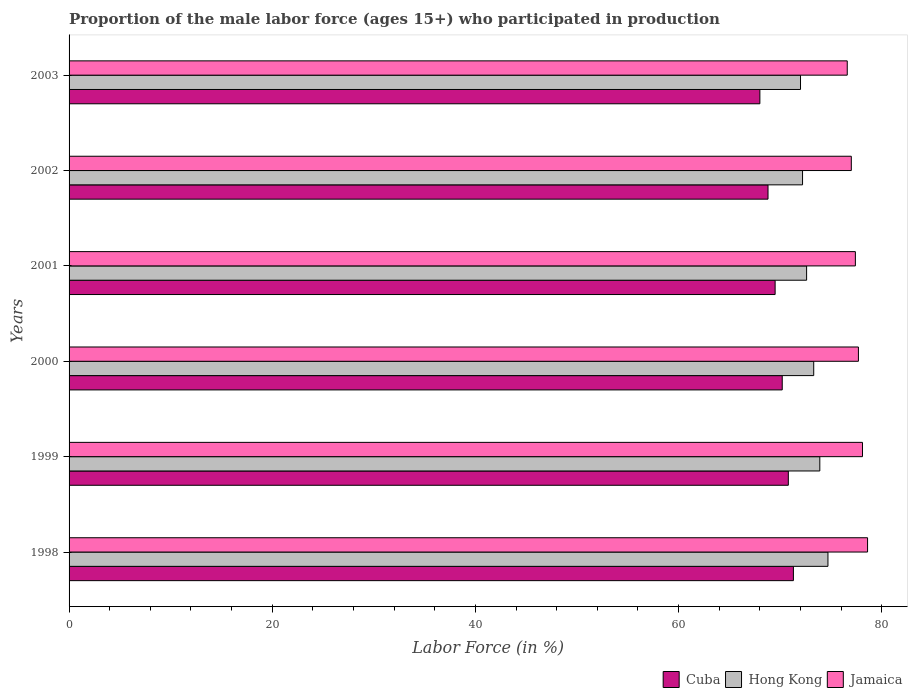How many different coloured bars are there?
Ensure brevity in your answer.  3. How many groups of bars are there?
Provide a succinct answer. 6. Are the number of bars on each tick of the Y-axis equal?
Make the answer very short. Yes. What is the label of the 2nd group of bars from the top?
Offer a terse response. 2002. In how many cases, is the number of bars for a given year not equal to the number of legend labels?
Offer a terse response. 0. What is the proportion of the male labor force who participated in production in Cuba in 2003?
Keep it short and to the point. 68. Across all years, what is the maximum proportion of the male labor force who participated in production in Cuba?
Give a very brief answer. 71.3. Across all years, what is the minimum proportion of the male labor force who participated in production in Jamaica?
Provide a short and direct response. 76.6. In which year was the proportion of the male labor force who participated in production in Cuba maximum?
Offer a very short reply. 1998. In which year was the proportion of the male labor force who participated in production in Cuba minimum?
Give a very brief answer. 2003. What is the total proportion of the male labor force who participated in production in Hong Kong in the graph?
Give a very brief answer. 438.7. What is the difference between the proportion of the male labor force who participated in production in Jamaica in 2000 and that in 2002?
Make the answer very short. 0.7. What is the difference between the proportion of the male labor force who participated in production in Hong Kong in 1999 and the proportion of the male labor force who participated in production in Cuba in 2003?
Your answer should be very brief. 5.9. What is the average proportion of the male labor force who participated in production in Hong Kong per year?
Keep it short and to the point. 73.12. In the year 2001, what is the difference between the proportion of the male labor force who participated in production in Hong Kong and proportion of the male labor force who participated in production in Cuba?
Your response must be concise. 3.1. In how many years, is the proportion of the male labor force who participated in production in Cuba greater than 4 %?
Give a very brief answer. 6. What is the ratio of the proportion of the male labor force who participated in production in Cuba in 2002 to that in 2003?
Your answer should be very brief. 1.01. Is the difference between the proportion of the male labor force who participated in production in Hong Kong in 2000 and 2002 greater than the difference between the proportion of the male labor force who participated in production in Cuba in 2000 and 2002?
Make the answer very short. No. Is the sum of the proportion of the male labor force who participated in production in Cuba in 1999 and 2000 greater than the maximum proportion of the male labor force who participated in production in Jamaica across all years?
Keep it short and to the point. Yes. What does the 2nd bar from the top in 2003 represents?
Ensure brevity in your answer.  Hong Kong. What does the 2nd bar from the bottom in 2000 represents?
Give a very brief answer. Hong Kong. Is it the case that in every year, the sum of the proportion of the male labor force who participated in production in Jamaica and proportion of the male labor force who participated in production in Cuba is greater than the proportion of the male labor force who participated in production in Hong Kong?
Your response must be concise. Yes. What is the difference between two consecutive major ticks on the X-axis?
Make the answer very short. 20. Are the values on the major ticks of X-axis written in scientific E-notation?
Your response must be concise. No. Where does the legend appear in the graph?
Keep it short and to the point. Bottom right. How are the legend labels stacked?
Provide a short and direct response. Horizontal. What is the title of the graph?
Make the answer very short. Proportion of the male labor force (ages 15+) who participated in production. What is the Labor Force (in %) of Cuba in 1998?
Ensure brevity in your answer.  71.3. What is the Labor Force (in %) in Hong Kong in 1998?
Give a very brief answer. 74.7. What is the Labor Force (in %) in Jamaica in 1998?
Your answer should be compact. 78.6. What is the Labor Force (in %) of Cuba in 1999?
Offer a terse response. 70.8. What is the Labor Force (in %) in Hong Kong in 1999?
Offer a terse response. 73.9. What is the Labor Force (in %) in Jamaica in 1999?
Your answer should be compact. 78.1. What is the Labor Force (in %) of Cuba in 2000?
Give a very brief answer. 70.2. What is the Labor Force (in %) in Hong Kong in 2000?
Your response must be concise. 73.3. What is the Labor Force (in %) in Jamaica in 2000?
Offer a very short reply. 77.7. What is the Labor Force (in %) of Cuba in 2001?
Your response must be concise. 69.5. What is the Labor Force (in %) in Hong Kong in 2001?
Offer a very short reply. 72.6. What is the Labor Force (in %) in Jamaica in 2001?
Ensure brevity in your answer.  77.4. What is the Labor Force (in %) in Cuba in 2002?
Give a very brief answer. 68.8. What is the Labor Force (in %) in Hong Kong in 2002?
Offer a terse response. 72.2. What is the Labor Force (in %) of Jamaica in 2002?
Your answer should be very brief. 77. What is the Labor Force (in %) of Jamaica in 2003?
Your answer should be compact. 76.6. Across all years, what is the maximum Labor Force (in %) in Cuba?
Provide a short and direct response. 71.3. Across all years, what is the maximum Labor Force (in %) of Hong Kong?
Your answer should be very brief. 74.7. Across all years, what is the maximum Labor Force (in %) in Jamaica?
Offer a very short reply. 78.6. Across all years, what is the minimum Labor Force (in %) of Hong Kong?
Your response must be concise. 72. Across all years, what is the minimum Labor Force (in %) of Jamaica?
Your answer should be very brief. 76.6. What is the total Labor Force (in %) of Cuba in the graph?
Offer a terse response. 418.6. What is the total Labor Force (in %) in Hong Kong in the graph?
Ensure brevity in your answer.  438.7. What is the total Labor Force (in %) of Jamaica in the graph?
Ensure brevity in your answer.  465.4. What is the difference between the Labor Force (in %) in Cuba in 1998 and that in 1999?
Offer a very short reply. 0.5. What is the difference between the Labor Force (in %) of Cuba in 1998 and that in 2000?
Provide a short and direct response. 1.1. What is the difference between the Labor Force (in %) in Hong Kong in 1998 and that in 2000?
Your answer should be very brief. 1.4. What is the difference between the Labor Force (in %) of Cuba in 1998 and that in 2001?
Your answer should be compact. 1.8. What is the difference between the Labor Force (in %) of Jamaica in 1998 and that in 2001?
Make the answer very short. 1.2. What is the difference between the Labor Force (in %) of Cuba in 1998 and that in 2002?
Your response must be concise. 2.5. What is the difference between the Labor Force (in %) in Hong Kong in 1998 and that in 2003?
Offer a very short reply. 2.7. What is the difference between the Labor Force (in %) in Jamaica in 1998 and that in 2003?
Offer a terse response. 2. What is the difference between the Labor Force (in %) in Cuba in 1999 and that in 2000?
Give a very brief answer. 0.6. What is the difference between the Labor Force (in %) in Hong Kong in 1999 and that in 2000?
Your answer should be compact. 0.6. What is the difference between the Labor Force (in %) of Jamaica in 1999 and that in 2000?
Give a very brief answer. 0.4. What is the difference between the Labor Force (in %) of Jamaica in 1999 and that in 2001?
Offer a very short reply. 0.7. What is the difference between the Labor Force (in %) in Jamaica in 1999 and that in 2002?
Make the answer very short. 1.1. What is the difference between the Labor Force (in %) of Cuba in 1999 and that in 2003?
Ensure brevity in your answer.  2.8. What is the difference between the Labor Force (in %) in Hong Kong in 1999 and that in 2003?
Ensure brevity in your answer.  1.9. What is the difference between the Labor Force (in %) in Cuba in 2000 and that in 2001?
Provide a succinct answer. 0.7. What is the difference between the Labor Force (in %) in Hong Kong in 2000 and that in 2001?
Offer a very short reply. 0.7. What is the difference between the Labor Force (in %) of Jamaica in 2000 and that in 2001?
Make the answer very short. 0.3. What is the difference between the Labor Force (in %) of Hong Kong in 2000 and that in 2002?
Give a very brief answer. 1.1. What is the difference between the Labor Force (in %) of Jamaica in 2000 and that in 2002?
Your response must be concise. 0.7. What is the difference between the Labor Force (in %) in Hong Kong in 2000 and that in 2003?
Give a very brief answer. 1.3. What is the difference between the Labor Force (in %) of Cuba in 2001 and that in 2002?
Ensure brevity in your answer.  0.7. What is the difference between the Labor Force (in %) of Cuba in 2001 and that in 2003?
Give a very brief answer. 1.5. What is the difference between the Labor Force (in %) in Jamaica in 2001 and that in 2003?
Provide a succinct answer. 0.8. What is the difference between the Labor Force (in %) of Hong Kong in 2002 and that in 2003?
Offer a terse response. 0.2. What is the difference between the Labor Force (in %) in Cuba in 1998 and the Labor Force (in %) in Jamaica in 2000?
Offer a terse response. -6.4. What is the difference between the Labor Force (in %) of Hong Kong in 1998 and the Labor Force (in %) of Jamaica in 2000?
Your answer should be compact. -3. What is the difference between the Labor Force (in %) in Cuba in 1998 and the Labor Force (in %) in Hong Kong in 2001?
Offer a terse response. -1.3. What is the difference between the Labor Force (in %) in Cuba in 1998 and the Labor Force (in %) in Jamaica in 2001?
Make the answer very short. -6.1. What is the difference between the Labor Force (in %) in Cuba in 1998 and the Labor Force (in %) in Hong Kong in 2002?
Your answer should be very brief. -0.9. What is the difference between the Labor Force (in %) in Hong Kong in 1998 and the Labor Force (in %) in Jamaica in 2002?
Offer a terse response. -2.3. What is the difference between the Labor Force (in %) of Cuba in 1998 and the Labor Force (in %) of Hong Kong in 2003?
Make the answer very short. -0.7. What is the difference between the Labor Force (in %) in Cuba in 1998 and the Labor Force (in %) in Jamaica in 2003?
Your response must be concise. -5.3. What is the difference between the Labor Force (in %) in Hong Kong in 1998 and the Labor Force (in %) in Jamaica in 2003?
Provide a succinct answer. -1.9. What is the difference between the Labor Force (in %) in Cuba in 1999 and the Labor Force (in %) in Hong Kong in 2000?
Ensure brevity in your answer.  -2.5. What is the difference between the Labor Force (in %) of Cuba in 1999 and the Labor Force (in %) of Jamaica in 2000?
Your response must be concise. -6.9. What is the difference between the Labor Force (in %) in Hong Kong in 1999 and the Labor Force (in %) in Jamaica in 2000?
Give a very brief answer. -3.8. What is the difference between the Labor Force (in %) of Cuba in 1999 and the Labor Force (in %) of Hong Kong in 2001?
Give a very brief answer. -1.8. What is the difference between the Labor Force (in %) in Cuba in 1999 and the Labor Force (in %) in Hong Kong in 2002?
Offer a terse response. -1.4. What is the difference between the Labor Force (in %) of Cuba in 1999 and the Labor Force (in %) of Jamaica in 2002?
Provide a short and direct response. -6.2. What is the difference between the Labor Force (in %) of Cuba in 1999 and the Labor Force (in %) of Hong Kong in 2003?
Your answer should be very brief. -1.2. What is the difference between the Labor Force (in %) of Cuba in 2000 and the Labor Force (in %) of Hong Kong in 2001?
Make the answer very short. -2.4. What is the difference between the Labor Force (in %) of Hong Kong in 2000 and the Labor Force (in %) of Jamaica in 2002?
Ensure brevity in your answer.  -3.7. What is the difference between the Labor Force (in %) of Hong Kong in 2000 and the Labor Force (in %) of Jamaica in 2003?
Provide a short and direct response. -3.3. What is the difference between the Labor Force (in %) of Cuba in 2001 and the Labor Force (in %) of Hong Kong in 2002?
Offer a very short reply. -2.7. What is the difference between the Labor Force (in %) of Cuba in 2001 and the Labor Force (in %) of Jamaica in 2003?
Keep it short and to the point. -7.1. What is the average Labor Force (in %) of Cuba per year?
Your response must be concise. 69.77. What is the average Labor Force (in %) of Hong Kong per year?
Give a very brief answer. 73.12. What is the average Labor Force (in %) of Jamaica per year?
Offer a very short reply. 77.57. In the year 1998, what is the difference between the Labor Force (in %) in Cuba and Labor Force (in %) in Hong Kong?
Offer a terse response. -3.4. In the year 1998, what is the difference between the Labor Force (in %) in Cuba and Labor Force (in %) in Jamaica?
Your answer should be compact. -7.3. In the year 1998, what is the difference between the Labor Force (in %) of Hong Kong and Labor Force (in %) of Jamaica?
Your answer should be compact. -3.9. In the year 1999, what is the difference between the Labor Force (in %) in Cuba and Labor Force (in %) in Jamaica?
Give a very brief answer. -7.3. In the year 2000, what is the difference between the Labor Force (in %) of Cuba and Labor Force (in %) of Jamaica?
Give a very brief answer. -7.5. In the year 2003, what is the difference between the Labor Force (in %) in Cuba and Labor Force (in %) in Hong Kong?
Make the answer very short. -4. What is the ratio of the Labor Force (in %) in Cuba in 1998 to that in 1999?
Ensure brevity in your answer.  1.01. What is the ratio of the Labor Force (in %) of Hong Kong in 1998 to that in 1999?
Make the answer very short. 1.01. What is the ratio of the Labor Force (in %) in Jamaica in 1998 to that in 1999?
Your answer should be compact. 1.01. What is the ratio of the Labor Force (in %) in Cuba in 1998 to that in 2000?
Provide a short and direct response. 1.02. What is the ratio of the Labor Force (in %) of Hong Kong in 1998 to that in 2000?
Your answer should be very brief. 1.02. What is the ratio of the Labor Force (in %) of Jamaica in 1998 to that in 2000?
Offer a terse response. 1.01. What is the ratio of the Labor Force (in %) in Cuba in 1998 to that in 2001?
Offer a terse response. 1.03. What is the ratio of the Labor Force (in %) of Hong Kong in 1998 to that in 2001?
Offer a terse response. 1.03. What is the ratio of the Labor Force (in %) of Jamaica in 1998 to that in 2001?
Ensure brevity in your answer.  1.02. What is the ratio of the Labor Force (in %) in Cuba in 1998 to that in 2002?
Your answer should be compact. 1.04. What is the ratio of the Labor Force (in %) in Hong Kong in 1998 to that in 2002?
Keep it short and to the point. 1.03. What is the ratio of the Labor Force (in %) of Jamaica in 1998 to that in 2002?
Ensure brevity in your answer.  1.02. What is the ratio of the Labor Force (in %) of Cuba in 1998 to that in 2003?
Make the answer very short. 1.05. What is the ratio of the Labor Force (in %) in Hong Kong in 1998 to that in 2003?
Make the answer very short. 1.04. What is the ratio of the Labor Force (in %) in Jamaica in 1998 to that in 2003?
Provide a succinct answer. 1.03. What is the ratio of the Labor Force (in %) of Cuba in 1999 to that in 2000?
Provide a succinct answer. 1.01. What is the ratio of the Labor Force (in %) of Hong Kong in 1999 to that in 2000?
Your response must be concise. 1.01. What is the ratio of the Labor Force (in %) of Cuba in 1999 to that in 2001?
Make the answer very short. 1.02. What is the ratio of the Labor Force (in %) of Hong Kong in 1999 to that in 2001?
Give a very brief answer. 1.02. What is the ratio of the Labor Force (in %) of Cuba in 1999 to that in 2002?
Your response must be concise. 1.03. What is the ratio of the Labor Force (in %) of Hong Kong in 1999 to that in 2002?
Offer a terse response. 1.02. What is the ratio of the Labor Force (in %) of Jamaica in 1999 to that in 2002?
Offer a very short reply. 1.01. What is the ratio of the Labor Force (in %) in Cuba in 1999 to that in 2003?
Your answer should be compact. 1.04. What is the ratio of the Labor Force (in %) in Hong Kong in 1999 to that in 2003?
Your answer should be very brief. 1.03. What is the ratio of the Labor Force (in %) of Jamaica in 1999 to that in 2003?
Your response must be concise. 1.02. What is the ratio of the Labor Force (in %) of Cuba in 2000 to that in 2001?
Provide a short and direct response. 1.01. What is the ratio of the Labor Force (in %) of Hong Kong in 2000 to that in 2001?
Ensure brevity in your answer.  1.01. What is the ratio of the Labor Force (in %) of Cuba in 2000 to that in 2002?
Provide a succinct answer. 1.02. What is the ratio of the Labor Force (in %) in Hong Kong in 2000 to that in 2002?
Keep it short and to the point. 1.02. What is the ratio of the Labor Force (in %) in Jamaica in 2000 to that in 2002?
Give a very brief answer. 1.01. What is the ratio of the Labor Force (in %) of Cuba in 2000 to that in 2003?
Your answer should be very brief. 1.03. What is the ratio of the Labor Force (in %) of Hong Kong in 2000 to that in 2003?
Provide a succinct answer. 1.02. What is the ratio of the Labor Force (in %) of Jamaica in 2000 to that in 2003?
Offer a terse response. 1.01. What is the ratio of the Labor Force (in %) of Cuba in 2001 to that in 2002?
Your answer should be compact. 1.01. What is the ratio of the Labor Force (in %) in Cuba in 2001 to that in 2003?
Offer a terse response. 1.02. What is the ratio of the Labor Force (in %) in Hong Kong in 2001 to that in 2003?
Provide a succinct answer. 1.01. What is the ratio of the Labor Force (in %) of Jamaica in 2001 to that in 2003?
Offer a terse response. 1.01. What is the ratio of the Labor Force (in %) of Cuba in 2002 to that in 2003?
Your answer should be very brief. 1.01. What is the ratio of the Labor Force (in %) in Jamaica in 2002 to that in 2003?
Your answer should be very brief. 1.01. What is the difference between the highest and the second highest Labor Force (in %) of Hong Kong?
Give a very brief answer. 0.8. 